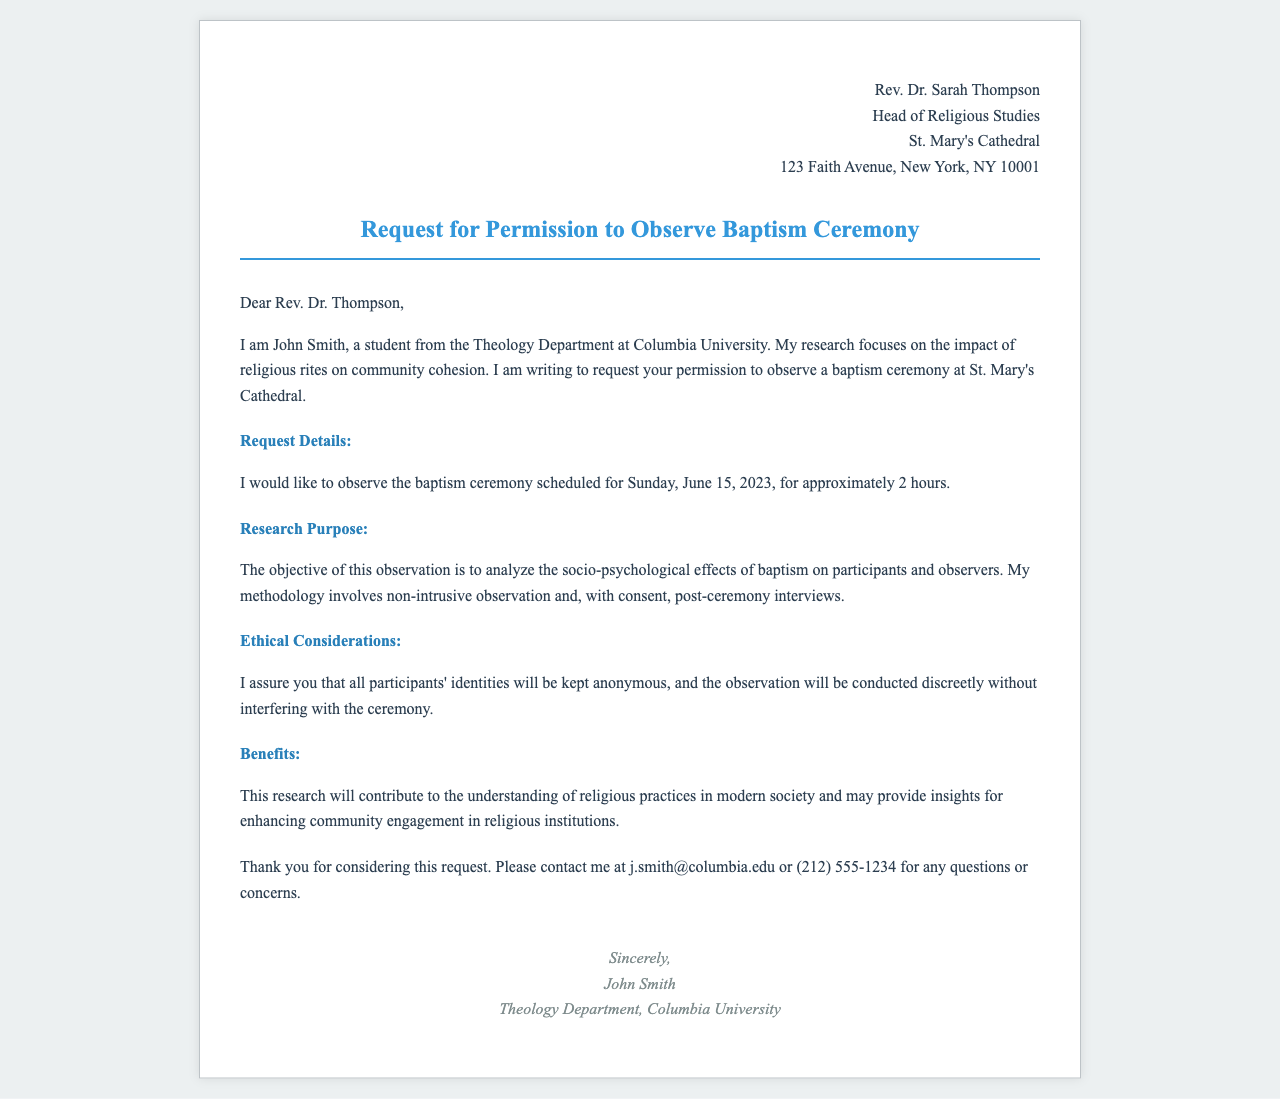What is the name of the sender? The sender's name is the person who wrote the request for permission, which is mentioned in the document.
Answer: John Smith What is the date of the observed baptism ceremony? The date of the ceremony is specified in the request for permission.
Answer: Sunday, June 15, 2023 What is the title of the recipient? The title of the recipient is indicated in the opening of the fax, giving their professional designation.
Answer: Rev. Dr. Thompson What is the aim of the research? The aim of the research is provided in the section detailing the purpose of the study.
Answer: Analyze the socio-psychological effects of baptism What is the duration for which the observation is requested? The duration of the requested observation is mentioned next to the specific details of the request.
Answer: Approximately 2 hours What ethical consideration is mentioned in the document? The ethical consideration indicates how participant privacy will be handled during the observation.
Answer: Identities will be kept anonymous What type of institution is St. Mary's Cathedral? The document gives context on the type of place where the baptism will take place.
Answer: Religious institution What type of research methodology will be used? The methodology mentioned in the document describes how the observation will be conducted.
Answer: Non-intrusive observation What is the contact email provided for further questions? The contact email is given in the closing part of the fax for any follow-up questions.
Answer: j.smith@columbia.edu 